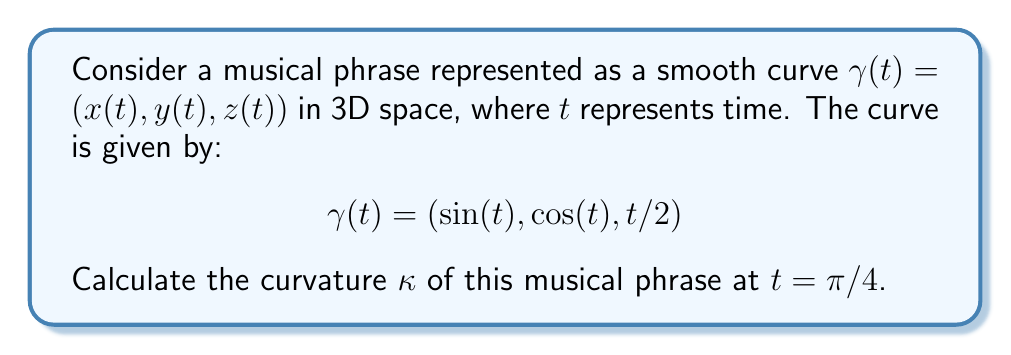Help me with this question. To calculate the curvature of the curve at $t = \pi/4$, we'll follow these steps:

1) The curvature formula for a parametric curve in 3D space is:

   $$\kappa = \frac{\|\gamma'(t) \times \gamma''(t)\|}{\|\gamma'(t)\|^3}$$

2) Calculate $\gamma'(t)$:
   $$\gamma'(t) = (\cos(t), -\sin(t), 1/2)$$

3) Calculate $\gamma''(t)$:
   $$\gamma''(t) = (-\sin(t), -\cos(t), 0)$$

4) Calculate $\gamma'(t) \times \gamma''(t)$:
   $$\gamma'(t) \times \gamma''(t) = \begin{vmatrix} 
   \mathbf{i} & \mathbf{j} & \mathbf{k} \\
   \cos(t) & -\sin(t) & 1/2 \\
   -\sin(t) & -\cos(t) & 0
   \end{vmatrix}$$
   
   $$= (-\frac{1}{2}\cos(t), -\frac{1}{2}\sin(t), -\cos^2(t)-\sin^2(t))$$
   
   $$= (-\frac{1}{2}\cos(t), -\frac{1}{2}\sin(t), -1)$$

5) Calculate $\|\gamma'(t) \times \gamma''(t)\|$:
   $$\|\gamma'(t) \times \gamma''(t)\| = \sqrt{(\frac{1}{2}\cos(t))^2 + (\frac{1}{2}\sin(t))^2 + 1^2}$$
   $$= \sqrt{\frac{1}{4}\cos^2(t) + \frac{1}{4}\sin^2(t) + 1} = \sqrt{\frac{1}{4} + 1} = \frac{\sqrt{5}}{2}$$

6) Calculate $\|\gamma'(t)\|$:
   $$\|\gamma'(t)\| = \sqrt{\cos^2(t) + \sin^2(t) + (\frac{1}{2})^2} = \sqrt{\frac{5}{4}}$$

7) Now, we can calculate the curvature:
   $$\kappa = \frac{\|\gamma'(t) \times \gamma''(t)\|}{\|\gamma'(t)\|^3} = \frac{\frac{\sqrt{5}}{2}}{(\sqrt{\frac{5}{4}})^3} = \frac{\sqrt{5}}{2} \cdot \frac{8}{5\sqrt{5}} = \frac{4}{5}$$

8) This result is constant for all $t$, including $t = \pi/4$.
Answer: $\kappa = \frac{4}{5}$ 